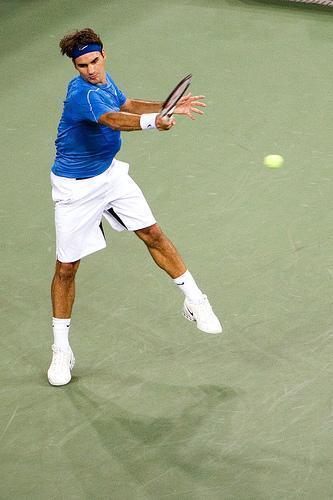How many feet does the man have in the air?
Give a very brief answer. 1. 